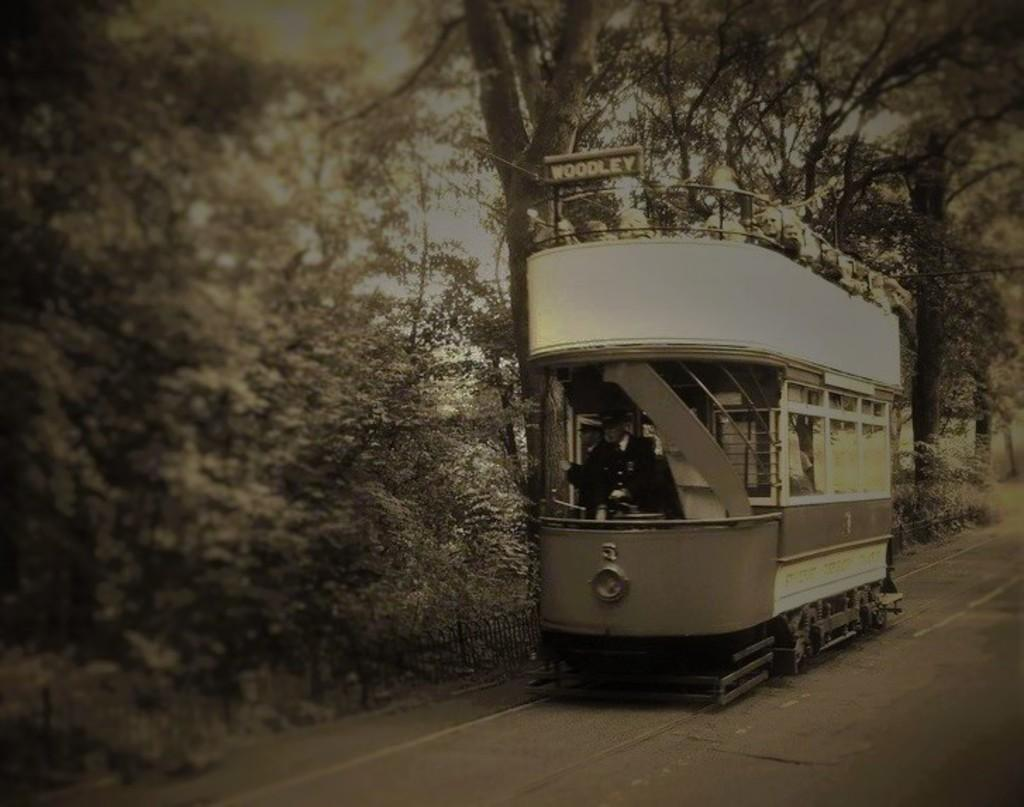What mode of transportation are the people in the image using? The people are on a train in the image. What can be seen in the background of the image? There are trees in the background of the image. What is visible at the bottom of the image? There is a road visible at the bottom of the image. Can you see the edge of the ocean in the image? There is no ocean present in the image; it features a train with people and trees in the background. 